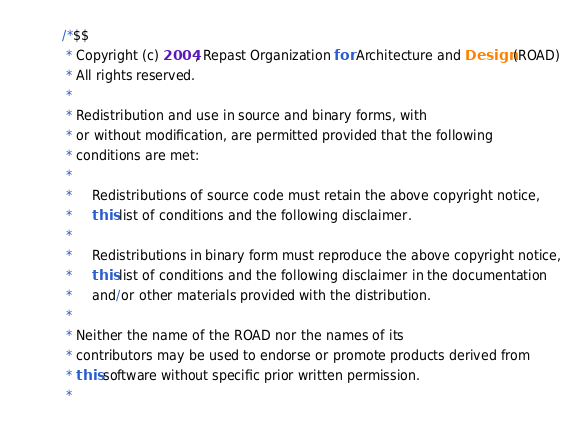Convert code to text. <code><loc_0><loc_0><loc_500><loc_500><_Java_>/*$$
 * Copyright (c) 2004, Repast Organization for Architecture and Design (ROAD)
 * All rights reserved.
 *
 * Redistribution and use in source and binary forms, with 
 * or without modification, are permitted provided that the following 
 * conditions are met:
 *
 *	 Redistributions of source code must retain the above copyright notice,
 *	 this list of conditions and the following disclaimer.
 *
 *	 Redistributions in binary form must reproduce the above copyright notice,
 *	 this list of conditions and the following disclaimer in the documentation
 *	 and/or other materials provided with the distribution.
 *
 * Neither the name of the ROAD nor the names of its
 * contributors may be used to endorse or promote products derived from
 * this software without specific prior written permission.
 *</code> 